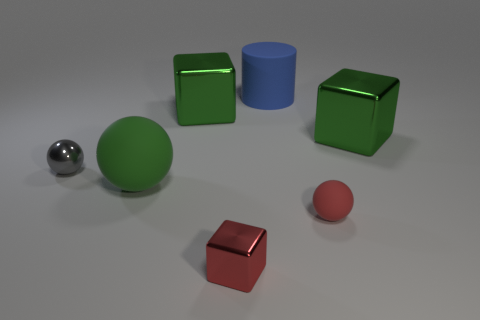What can you tell me about the lighting in the scene? The lighting in the scene is diffuse and seems to come from a broad overhead source, casting soft shadows directly under the objects with slight variations in the shadow lengths, indicating the light source is not directly above. How does the lighting affect the mood of the scene? The soft and even lighting creates a calm and neutral atmosphere in the scene. It minimizes harsh contrasts and allows the colors of the objects to be seen clearly, enhancing the perception of their textures and shapes. 